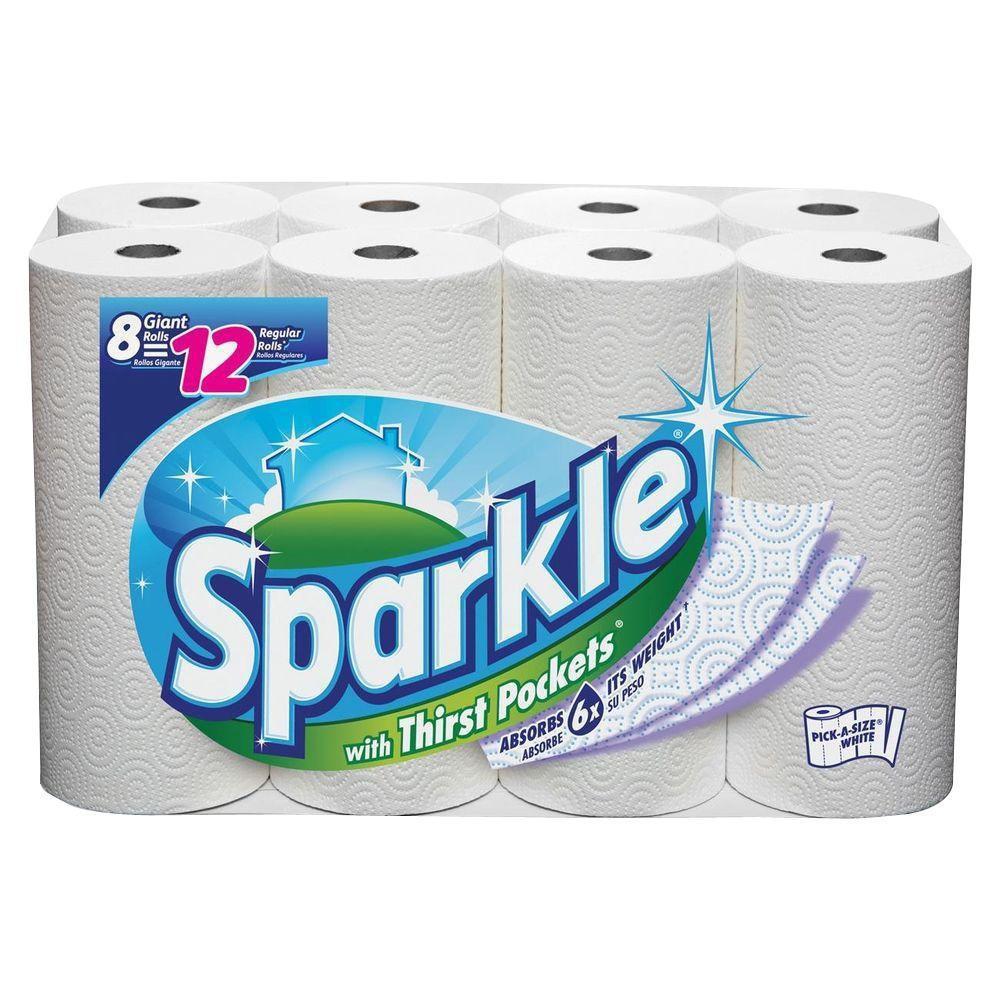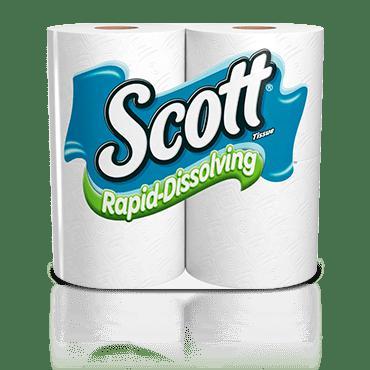The first image is the image on the left, the second image is the image on the right. For the images shown, is this caption "There are two multi-packs of paper towels." true? Answer yes or no. Yes. The first image is the image on the left, the second image is the image on the right. Given the left and right images, does the statement "The left image shows one multi-roll package of towels with a starburst shape on the front of the pack, and the package on the right features a blue curving line." hold true? Answer yes or no. Yes. 